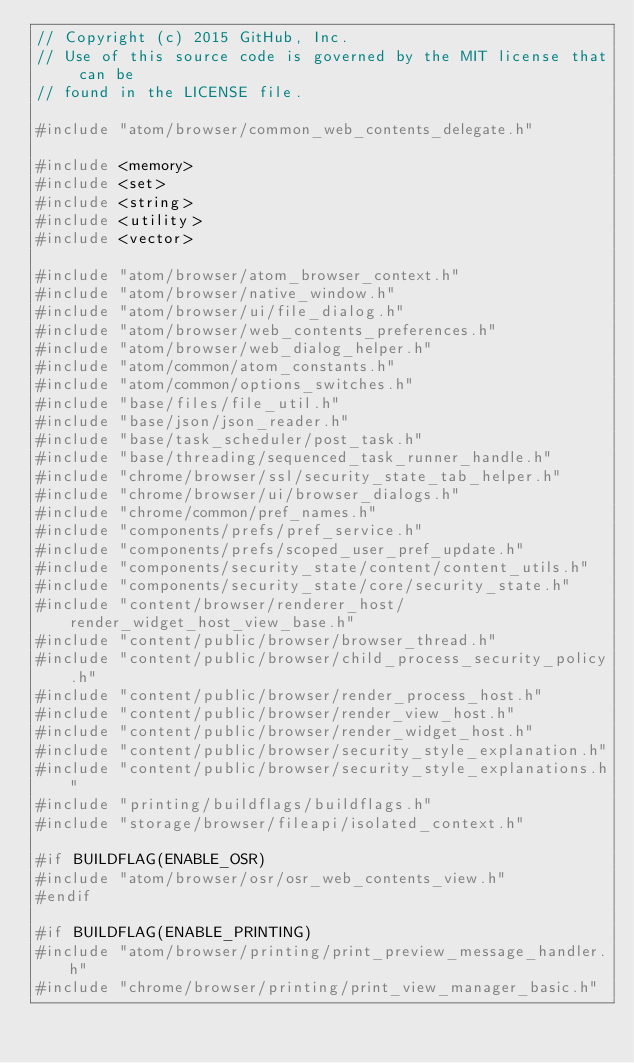Convert code to text. <code><loc_0><loc_0><loc_500><loc_500><_C++_>// Copyright (c) 2015 GitHub, Inc.
// Use of this source code is governed by the MIT license that can be
// found in the LICENSE file.

#include "atom/browser/common_web_contents_delegate.h"

#include <memory>
#include <set>
#include <string>
#include <utility>
#include <vector>

#include "atom/browser/atom_browser_context.h"
#include "atom/browser/native_window.h"
#include "atom/browser/ui/file_dialog.h"
#include "atom/browser/web_contents_preferences.h"
#include "atom/browser/web_dialog_helper.h"
#include "atom/common/atom_constants.h"
#include "atom/common/options_switches.h"
#include "base/files/file_util.h"
#include "base/json/json_reader.h"
#include "base/task_scheduler/post_task.h"
#include "base/threading/sequenced_task_runner_handle.h"
#include "chrome/browser/ssl/security_state_tab_helper.h"
#include "chrome/browser/ui/browser_dialogs.h"
#include "chrome/common/pref_names.h"
#include "components/prefs/pref_service.h"
#include "components/prefs/scoped_user_pref_update.h"
#include "components/security_state/content/content_utils.h"
#include "components/security_state/core/security_state.h"
#include "content/browser/renderer_host/render_widget_host_view_base.h"
#include "content/public/browser/browser_thread.h"
#include "content/public/browser/child_process_security_policy.h"
#include "content/public/browser/render_process_host.h"
#include "content/public/browser/render_view_host.h"
#include "content/public/browser/render_widget_host.h"
#include "content/public/browser/security_style_explanation.h"
#include "content/public/browser/security_style_explanations.h"
#include "printing/buildflags/buildflags.h"
#include "storage/browser/fileapi/isolated_context.h"

#if BUILDFLAG(ENABLE_OSR)
#include "atom/browser/osr/osr_web_contents_view.h"
#endif

#if BUILDFLAG(ENABLE_PRINTING)
#include "atom/browser/printing/print_preview_message_handler.h"
#include "chrome/browser/printing/print_view_manager_basic.h"</code> 